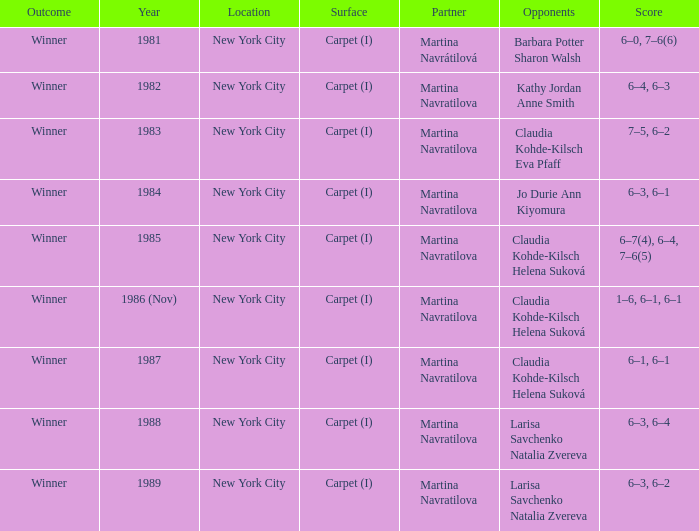Can you list all the opponents present in 1984? Jo Durie Ann Kiyomura. 